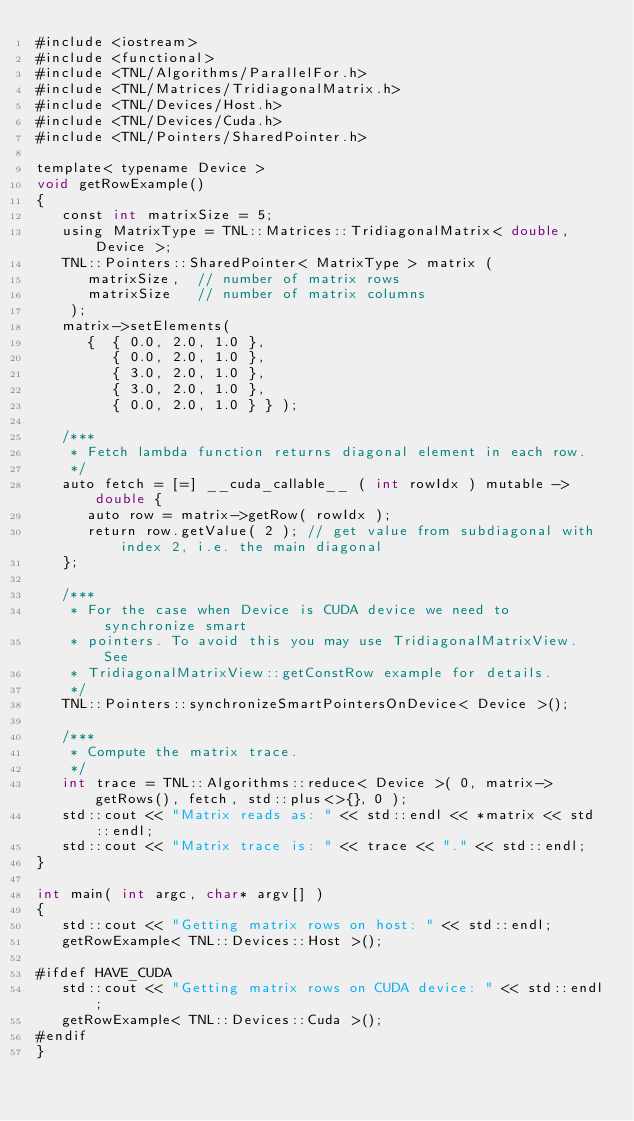<code> <loc_0><loc_0><loc_500><loc_500><_Cuda_>#include <iostream>
#include <functional>
#include <TNL/Algorithms/ParallelFor.h>
#include <TNL/Matrices/TridiagonalMatrix.h>
#include <TNL/Devices/Host.h>
#include <TNL/Devices/Cuda.h>
#include <TNL/Pointers/SharedPointer.h>

template< typename Device >
void getRowExample()
{
   const int matrixSize = 5;
   using MatrixType = TNL::Matrices::TridiagonalMatrix< double, Device >;
   TNL::Pointers::SharedPointer< MatrixType > matrix (
      matrixSize,  // number of matrix rows
      matrixSize   // number of matrix columns
    );
   matrix->setElements(
      {  { 0.0, 2.0, 1.0 },
         { 0.0, 2.0, 1.0 },
         { 3.0, 2.0, 1.0 },
         { 3.0, 2.0, 1.0 },
         { 0.0, 2.0, 1.0 } } );

   /***
    * Fetch lambda function returns diagonal element in each row.
    */
   auto fetch = [=] __cuda_callable__ ( int rowIdx ) mutable -> double {
      auto row = matrix->getRow( rowIdx );
      return row.getValue( 2 ); // get value from subdiagonal with index 2, i.e. the main diagonal
   };

   /***
    * For the case when Device is CUDA device we need to synchronize smart
    * pointers. To avoid this you may use TridiagonalMatrixView. See
    * TridiagonalMatrixView::getConstRow example for details.
    */
   TNL::Pointers::synchronizeSmartPointersOnDevice< Device >();

   /***
    * Compute the matrix trace.
    */
   int trace = TNL::Algorithms::reduce< Device >( 0, matrix->getRows(), fetch, std::plus<>{}, 0 );
   std::cout << "Matrix reads as: " << std::endl << *matrix << std::endl;
   std::cout << "Matrix trace is: " << trace << "." << std::endl;
}

int main( int argc, char* argv[] )
{
   std::cout << "Getting matrix rows on host: " << std::endl;
   getRowExample< TNL::Devices::Host >();

#ifdef HAVE_CUDA
   std::cout << "Getting matrix rows on CUDA device: " << std::endl;
   getRowExample< TNL::Devices::Cuda >();
#endif
}
</code> 